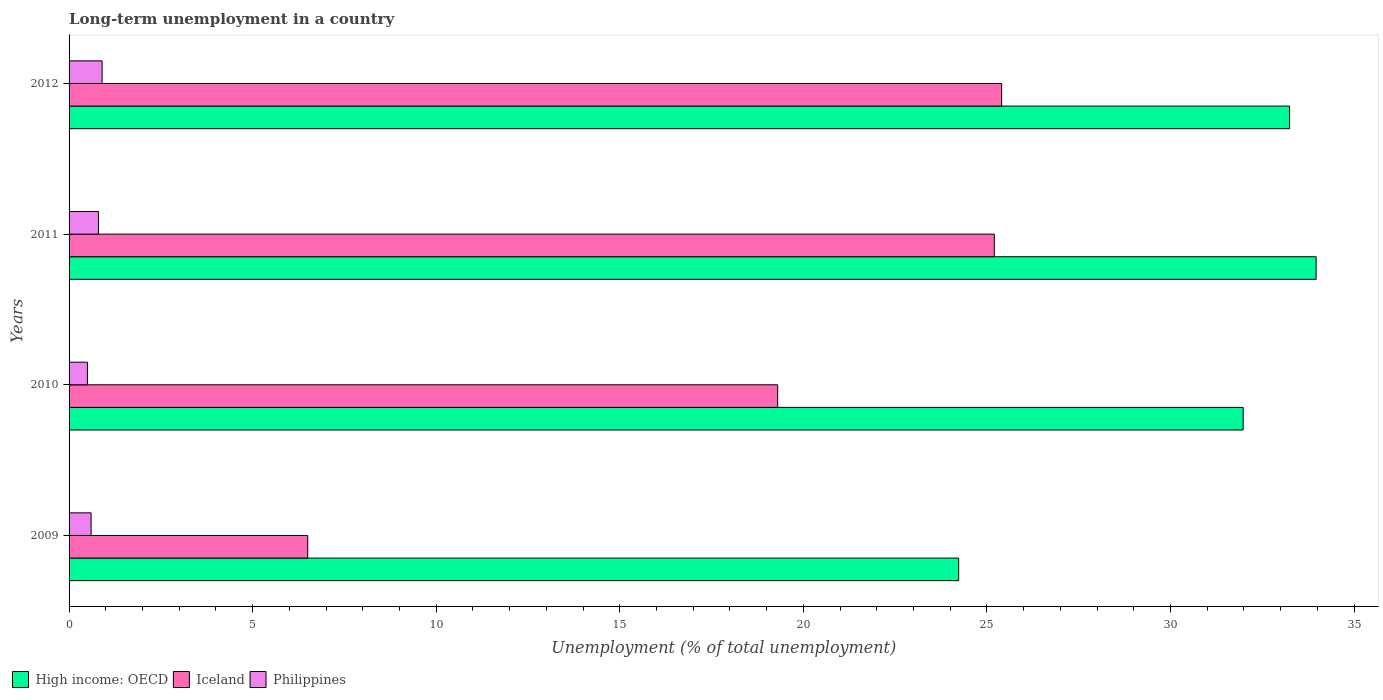How many bars are there on the 3rd tick from the bottom?
Offer a very short reply. 3. In how many cases, is the number of bars for a given year not equal to the number of legend labels?
Offer a very short reply. 0. What is the percentage of long-term unemployed population in High income: OECD in 2009?
Offer a terse response. 24.23. Across all years, what is the maximum percentage of long-term unemployed population in High income: OECD?
Provide a short and direct response. 33.97. In which year was the percentage of long-term unemployed population in Iceland minimum?
Give a very brief answer. 2009. What is the total percentage of long-term unemployed population in Philippines in the graph?
Keep it short and to the point. 2.8. What is the difference between the percentage of long-term unemployed population in Iceland in 2011 and that in 2012?
Offer a very short reply. -0.2. What is the difference between the percentage of long-term unemployed population in Philippines in 2010 and the percentage of long-term unemployed population in High income: OECD in 2009?
Keep it short and to the point. -23.73. What is the average percentage of long-term unemployed population in Iceland per year?
Ensure brevity in your answer.  19.1. In the year 2011, what is the difference between the percentage of long-term unemployed population in Iceland and percentage of long-term unemployed population in High income: OECD?
Offer a terse response. -8.77. In how many years, is the percentage of long-term unemployed population in Iceland greater than 31 %?
Make the answer very short. 0. What is the ratio of the percentage of long-term unemployed population in Philippines in 2009 to that in 2012?
Keep it short and to the point. 0.67. Is the percentage of long-term unemployed population in Philippines in 2010 less than that in 2012?
Your response must be concise. Yes. Is the difference between the percentage of long-term unemployed population in Iceland in 2009 and 2011 greater than the difference between the percentage of long-term unemployed population in High income: OECD in 2009 and 2011?
Ensure brevity in your answer.  No. What is the difference between the highest and the second highest percentage of long-term unemployed population in Philippines?
Give a very brief answer. 0.1. What is the difference between the highest and the lowest percentage of long-term unemployed population in Iceland?
Your answer should be compact. 18.9. In how many years, is the percentage of long-term unemployed population in Philippines greater than the average percentage of long-term unemployed population in Philippines taken over all years?
Provide a short and direct response. 2. What does the 3rd bar from the top in 2010 represents?
Your response must be concise. High income: OECD. What does the 1st bar from the bottom in 2010 represents?
Your response must be concise. High income: OECD. Is it the case that in every year, the sum of the percentage of long-term unemployed population in Philippines and percentage of long-term unemployed population in Iceland is greater than the percentage of long-term unemployed population in High income: OECD?
Provide a short and direct response. No. How many years are there in the graph?
Your answer should be very brief. 4. What is the difference between two consecutive major ticks on the X-axis?
Ensure brevity in your answer.  5. Does the graph contain any zero values?
Your answer should be compact. No. Does the graph contain grids?
Give a very brief answer. No. Where does the legend appear in the graph?
Your answer should be very brief. Bottom left. How are the legend labels stacked?
Your answer should be compact. Horizontal. What is the title of the graph?
Offer a very short reply. Long-term unemployment in a country. What is the label or title of the X-axis?
Provide a short and direct response. Unemployment (% of total unemployment). What is the label or title of the Y-axis?
Provide a short and direct response. Years. What is the Unemployment (% of total unemployment) in High income: OECD in 2009?
Your answer should be compact. 24.23. What is the Unemployment (% of total unemployment) in Philippines in 2009?
Give a very brief answer. 0.6. What is the Unemployment (% of total unemployment) in High income: OECD in 2010?
Give a very brief answer. 31.98. What is the Unemployment (% of total unemployment) of Iceland in 2010?
Provide a short and direct response. 19.3. What is the Unemployment (% of total unemployment) of Philippines in 2010?
Offer a terse response. 0.5. What is the Unemployment (% of total unemployment) of High income: OECD in 2011?
Give a very brief answer. 33.97. What is the Unemployment (% of total unemployment) in Iceland in 2011?
Keep it short and to the point. 25.2. What is the Unemployment (% of total unemployment) of Philippines in 2011?
Make the answer very short. 0.8. What is the Unemployment (% of total unemployment) in High income: OECD in 2012?
Offer a very short reply. 33.24. What is the Unemployment (% of total unemployment) of Iceland in 2012?
Your response must be concise. 25.4. What is the Unemployment (% of total unemployment) in Philippines in 2012?
Ensure brevity in your answer.  0.9. Across all years, what is the maximum Unemployment (% of total unemployment) in High income: OECD?
Ensure brevity in your answer.  33.97. Across all years, what is the maximum Unemployment (% of total unemployment) in Iceland?
Your answer should be compact. 25.4. Across all years, what is the maximum Unemployment (% of total unemployment) of Philippines?
Provide a succinct answer. 0.9. Across all years, what is the minimum Unemployment (% of total unemployment) in High income: OECD?
Make the answer very short. 24.23. What is the total Unemployment (% of total unemployment) in High income: OECD in the graph?
Give a very brief answer. 123.42. What is the total Unemployment (% of total unemployment) of Iceland in the graph?
Provide a succinct answer. 76.4. What is the total Unemployment (% of total unemployment) in Philippines in the graph?
Your answer should be compact. 2.8. What is the difference between the Unemployment (% of total unemployment) of High income: OECD in 2009 and that in 2010?
Offer a terse response. -7.75. What is the difference between the Unemployment (% of total unemployment) in Iceland in 2009 and that in 2010?
Ensure brevity in your answer.  -12.8. What is the difference between the Unemployment (% of total unemployment) in High income: OECD in 2009 and that in 2011?
Your response must be concise. -9.74. What is the difference between the Unemployment (% of total unemployment) of Iceland in 2009 and that in 2011?
Ensure brevity in your answer.  -18.7. What is the difference between the Unemployment (% of total unemployment) of High income: OECD in 2009 and that in 2012?
Provide a short and direct response. -9.01. What is the difference between the Unemployment (% of total unemployment) in Iceland in 2009 and that in 2012?
Keep it short and to the point. -18.9. What is the difference between the Unemployment (% of total unemployment) in Philippines in 2009 and that in 2012?
Your response must be concise. -0.3. What is the difference between the Unemployment (% of total unemployment) in High income: OECD in 2010 and that in 2011?
Your response must be concise. -1.99. What is the difference between the Unemployment (% of total unemployment) of Iceland in 2010 and that in 2011?
Your answer should be compact. -5.9. What is the difference between the Unemployment (% of total unemployment) in High income: OECD in 2010 and that in 2012?
Your answer should be compact. -1.26. What is the difference between the Unemployment (% of total unemployment) of High income: OECD in 2011 and that in 2012?
Your answer should be compact. 0.72. What is the difference between the Unemployment (% of total unemployment) in Iceland in 2011 and that in 2012?
Give a very brief answer. -0.2. What is the difference between the Unemployment (% of total unemployment) of Philippines in 2011 and that in 2012?
Your response must be concise. -0.1. What is the difference between the Unemployment (% of total unemployment) in High income: OECD in 2009 and the Unemployment (% of total unemployment) in Iceland in 2010?
Ensure brevity in your answer.  4.93. What is the difference between the Unemployment (% of total unemployment) of High income: OECD in 2009 and the Unemployment (% of total unemployment) of Philippines in 2010?
Your answer should be compact. 23.73. What is the difference between the Unemployment (% of total unemployment) in Iceland in 2009 and the Unemployment (% of total unemployment) in Philippines in 2010?
Ensure brevity in your answer.  6. What is the difference between the Unemployment (% of total unemployment) of High income: OECD in 2009 and the Unemployment (% of total unemployment) of Iceland in 2011?
Keep it short and to the point. -0.97. What is the difference between the Unemployment (% of total unemployment) in High income: OECD in 2009 and the Unemployment (% of total unemployment) in Philippines in 2011?
Offer a very short reply. 23.43. What is the difference between the Unemployment (% of total unemployment) in Iceland in 2009 and the Unemployment (% of total unemployment) in Philippines in 2011?
Offer a terse response. 5.7. What is the difference between the Unemployment (% of total unemployment) in High income: OECD in 2009 and the Unemployment (% of total unemployment) in Iceland in 2012?
Ensure brevity in your answer.  -1.17. What is the difference between the Unemployment (% of total unemployment) in High income: OECD in 2009 and the Unemployment (% of total unemployment) in Philippines in 2012?
Keep it short and to the point. 23.33. What is the difference between the Unemployment (% of total unemployment) in Iceland in 2009 and the Unemployment (% of total unemployment) in Philippines in 2012?
Your answer should be compact. 5.6. What is the difference between the Unemployment (% of total unemployment) in High income: OECD in 2010 and the Unemployment (% of total unemployment) in Iceland in 2011?
Provide a succinct answer. 6.78. What is the difference between the Unemployment (% of total unemployment) of High income: OECD in 2010 and the Unemployment (% of total unemployment) of Philippines in 2011?
Your response must be concise. 31.18. What is the difference between the Unemployment (% of total unemployment) of High income: OECD in 2010 and the Unemployment (% of total unemployment) of Iceland in 2012?
Your answer should be compact. 6.58. What is the difference between the Unemployment (% of total unemployment) of High income: OECD in 2010 and the Unemployment (% of total unemployment) of Philippines in 2012?
Offer a very short reply. 31.08. What is the difference between the Unemployment (% of total unemployment) of High income: OECD in 2011 and the Unemployment (% of total unemployment) of Iceland in 2012?
Your response must be concise. 8.57. What is the difference between the Unemployment (% of total unemployment) in High income: OECD in 2011 and the Unemployment (% of total unemployment) in Philippines in 2012?
Give a very brief answer. 33.07. What is the difference between the Unemployment (% of total unemployment) of Iceland in 2011 and the Unemployment (% of total unemployment) of Philippines in 2012?
Make the answer very short. 24.3. What is the average Unemployment (% of total unemployment) of High income: OECD per year?
Offer a very short reply. 30.85. In the year 2009, what is the difference between the Unemployment (% of total unemployment) in High income: OECD and Unemployment (% of total unemployment) in Iceland?
Ensure brevity in your answer.  17.73. In the year 2009, what is the difference between the Unemployment (% of total unemployment) in High income: OECD and Unemployment (% of total unemployment) in Philippines?
Give a very brief answer. 23.63. In the year 2010, what is the difference between the Unemployment (% of total unemployment) in High income: OECD and Unemployment (% of total unemployment) in Iceland?
Your response must be concise. 12.68. In the year 2010, what is the difference between the Unemployment (% of total unemployment) of High income: OECD and Unemployment (% of total unemployment) of Philippines?
Provide a succinct answer. 31.48. In the year 2010, what is the difference between the Unemployment (% of total unemployment) of Iceland and Unemployment (% of total unemployment) of Philippines?
Give a very brief answer. 18.8. In the year 2011, what is the difference between the Unemployment (% of total unemployment) in High income: OECD and Unemployment (% of total unemployment) in Iceland?
Offer a very short reply. 8.77. In the year 2011, what is the difference between the Unemployment (% of total unemployment) in High income: OECD and Unemployment (% of total unemployment) in Philippines?
Provide a short and direct response. 33.17. In the year 2011, what is the difference between the Unemployment (% of total unemployment) in Iceland and Unemployment (% of total unemployment) in Philippines?
Provide a succinct answer. 24.4. In the year 2012, what is the difference between the Unemployment (% of total unemployment) of High income: OECD and Unemployment (% of total unemployment) of Iceland?
Your answer should be compact. 7.84. In the year 2012, what is the difference between the Unemployment (% of total unemployment) of High income: OECD and Unemployment (% of total unemployment) of Philippines?
Provide a succinct answer. 32.34. In the year 2012, what is the difference between the Unemployment (% of total unemployment) in Iceland and Unemployment (% of total unemployment) in Philippines?
Provide a succinct answer. 24.5. What is the ratio of the Unemployment (% of total unemployment) in High income: OECD in 2009 to that in 2010?
Provide a succinct answer. 0.76. What is the ratio of the Unemployment (% of total unemployment) in Iceland in 2009 to that in 2010?
Keep it short and to the point. 0.34. What is the ratio of the Unemployment (% of total unemployment) in Philippines in 2009 to that in 2010?
Keep it short and to the point. 1.2. What is the ratio of the Unemployment (% of total unemployment) of High income: OECD in 2009 to that in 2011?
Give a very brief answer. 0.71. What is the ratio of the Unemployment (% of total unemployment) of Iceland in 2009 to that in 2011?
Make the answer very short. 0.26. What is the ratio of the Unemployment (% of total unemployment) in Philippines in 2009 to that in 2011?
Your answer should be compact. 0.75. What is the ratio of the Unemployment (% of total unemployment) of High income: OECD in 2009 to that in 2012?
Offer a very short reply. 0.73. What is the ratio of the Unemployment (% of total unemployment) of Iceland in 2009 to that in 2012?
Offer a terse response. 0.26. What is the ratio of the Unemployment (% of total unemployment) of Philippines in 2009 to that in 2012?
Keep it short and to the point. 0.67. What is the ratio of the Unemployment (% of total unemployment) in High income: OECD in 2010 to that in 2011?
Your answer should be very brief. 0.94. What is the ratio of the Unemployment (% of total unemployment) in Iceland in 2010 to that in 2011?
Provide a succinct answer. 0.77. What is the ratio of the Unemployment (% of total unemployment) of Iceland in 2010 to that in 2012?
Ensure brevity in your answer.  0.76. What is the ratio of the Unemployment (% of total unemployment) of Philippines in 2010 to that in 2012?
Keep it short and to the point. 0.56. What is the ratio of the Unemployment (% of total unemployment) of High income: OECD in 2011 to that in 2012?
Offer a terse response. 1.02. What is the ratio of the Unemployment (% of total unemployment) of Iceland in 2011 to that in 2012?
Your answer should be very brief. 0.99. What is the difference between the highest and the second highest Unemployment (% of total unemployment) of High income: OECD?
Make the answer very short. 0.72. What is the difference between the highest and the second highest Unemployment (% of total unemployment) of Iceland?
Your answer should be compact. 0.2. What is the difference between the highest and the second highest Unemployment (% of total unemployment) of Philippines?
Offer a very short reply. 0.1. What is the difference between the highest and the lowest Unemployment (% of total unemployment) in High income: OECD?
Give a very brief answer. 9.74. What is the difference between the highest and the lowest Unemployment (% of total unemployment) in Philippines?
Provide a short and direct response. 0.4. 